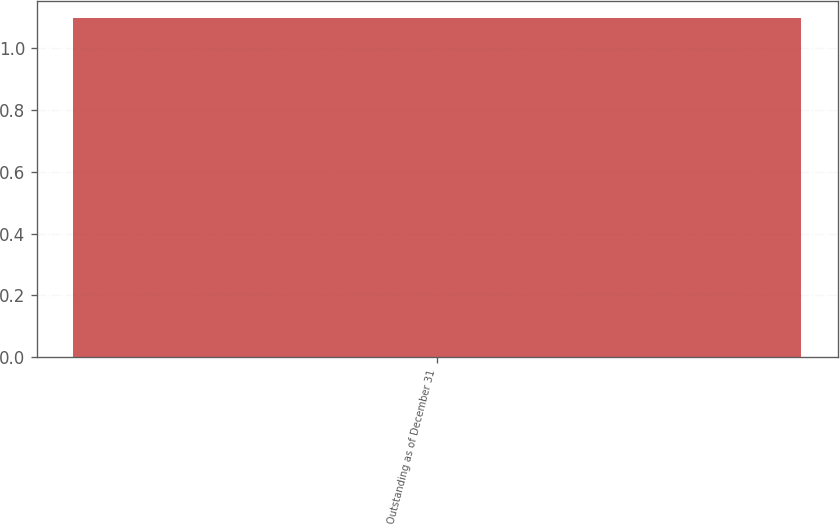Convert chart. <chart><loc_0><loc_0><loc_500><loc_500><bar_chart><fcel>Outstanding as of December 31<nl><fcel>1.1<nl></chart> 